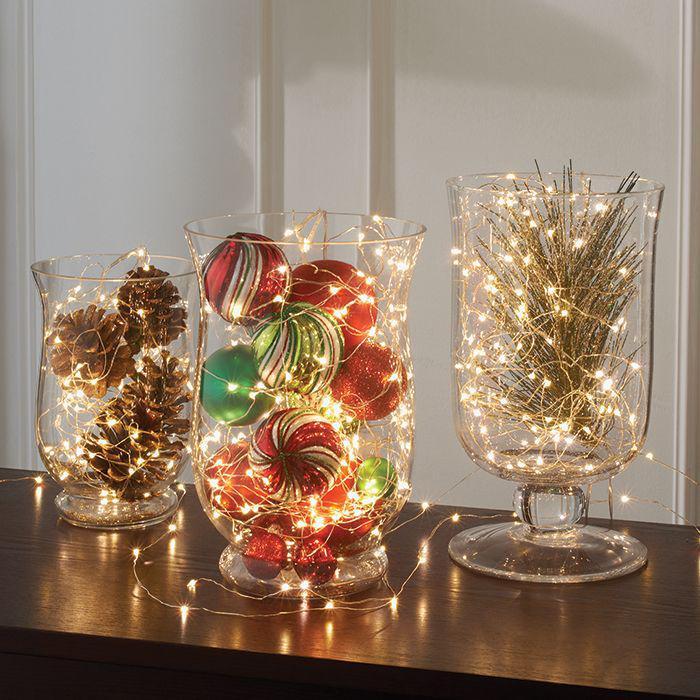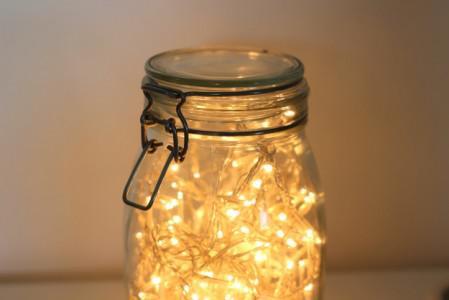The first image is the image on the left, the second image is the image on the right. Considering the images on both sides, is "At least 1 glass container is decorated with pine cones and lights." valid? Answer yes or no. Yes. The first image is the image on the left, the second image is the image on the right. Given the left and right images, does the statement "There are pine cones in at least one clear glass vase with stringed lights inside with them." hold true? Answer yes or no. Yes. 